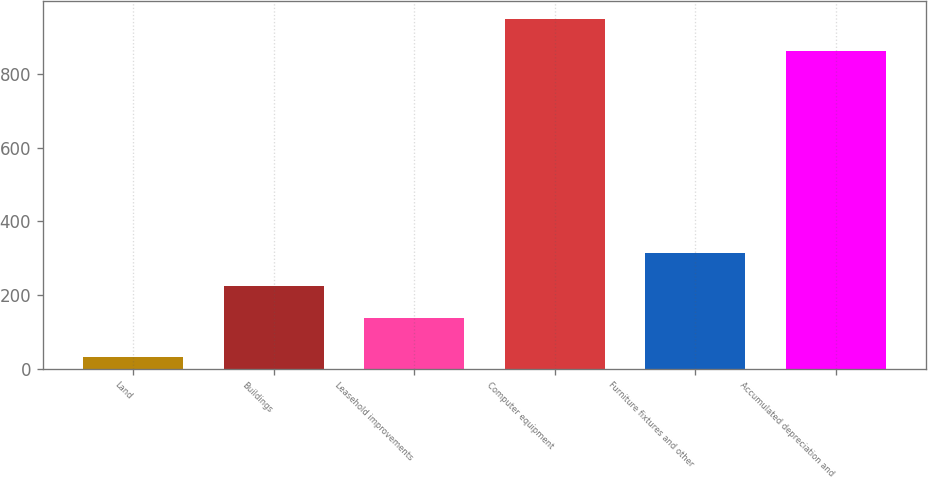<chart> <loc_0><loc_0><loc_500><loc_500><bar_chart><fcel>Land<fcel>Buildings<fcel>Leasehold improvements<fcel>Computer equipment<fcel>Furniture fixtures and other<fcel>Accumulated depreciation and<nl><fcel>31<fcel>224.8<fcel>137<fcel>949.8<fcel>312.6<fcel>862<nl></chart> 